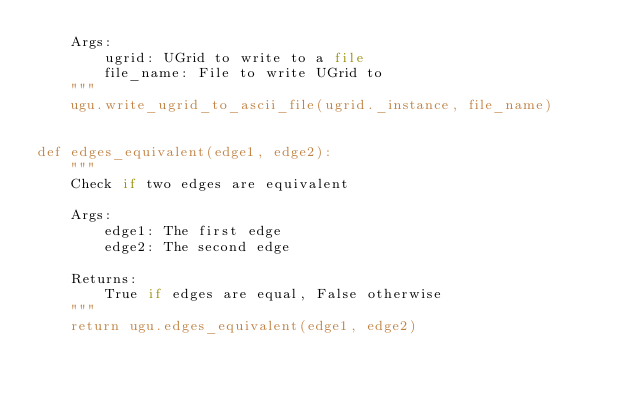<code> <loc_0><loc_0><loc_500><loc_500><_Python_>    Args:
        ugrid: UGrid to write to a file
        file_name: File to write UGrid to
    """
    ugu.write_ugrid_to_ascii_file(ugrid._instance, file_name)


def edges_equivalent(edge1, edge2):
    """
    Check if two edges are equivalent

    Args:
        edge1: The first edge
        edge2: The second edge

    Returns:
        True if edges are equal, False otherwise
    """
    return ugu.edges_equivalent(edge1, edge2)
</code> 